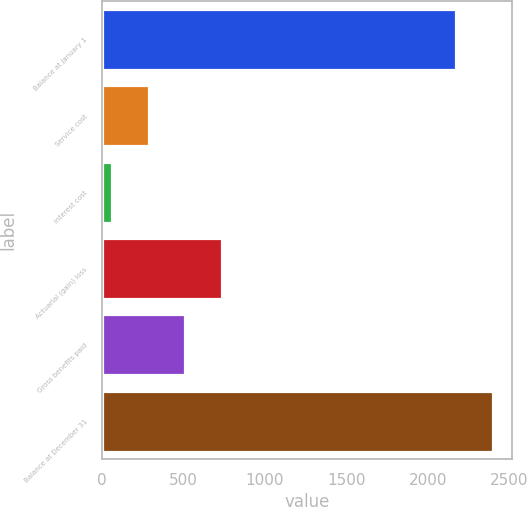<chart> <loc_0><loc_0><loc_500><loc_500><bar_chart><fcel>Balance at January 1<fcel>Service cost<fcel>Interest cost<fcel>Actuarial (gain) loss<fcel>Gross benefits paid<fcel>Balance at December 31<nl><fcel>2175<fcel>287.2<fcel>62<fcel>737.6<fcel>512.4<fcel>2400.2<nl></chart> 